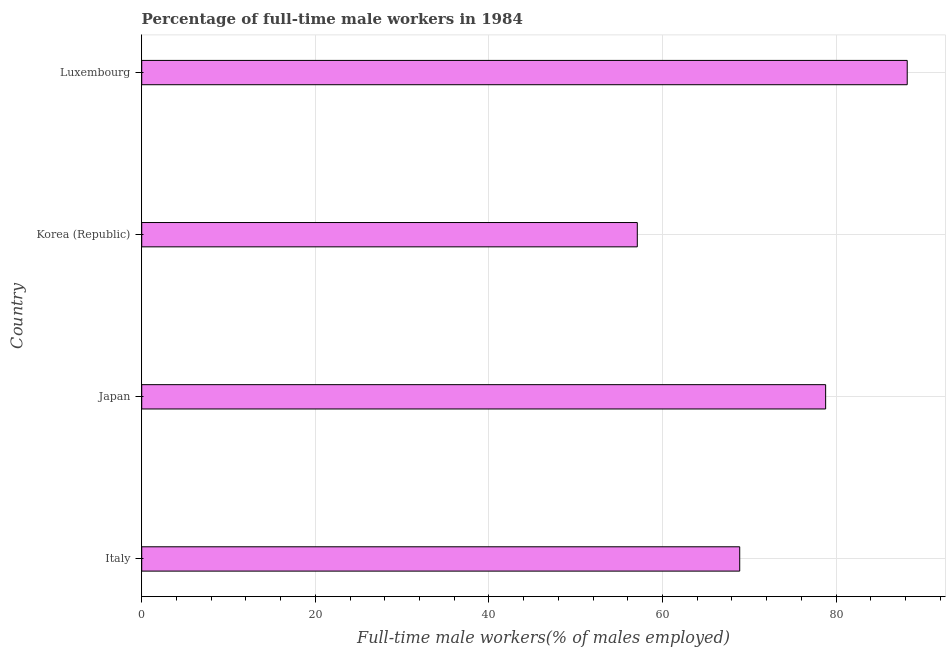What is the title of the graph?
Keep it short and to the point. Percentage of full-time male workers in 1984. What is the label or title of the X-axis?
Offer a terse response. Full-time male workers(% of males employed). What is the label or title of the Y-axis?
Provide a succinct answer. Country. What is the percentage of full-time male workers in Korea (Republic)?
Provide a short and direct response. 57.1. Across all countries, what is the maximum percentage of full-time male workers?
Offer a terse response. 88.2. Across all countries, what is the minimum percentage of full-time male workers?
Ensure brevity in your answer.  57.1. In which country was the percentage of full-time male workers maximum?
Offer a very short reply. Luxembourg. In which country was the percentage of full-time male workers minimum?
Your answer should be very brief. Korea (Republic). What is the sum of the percentage of full-time male workers?
Ensure brevity in your answer.  293. What is the difference between the percentage of full-time male workers in Japan and Korea (Republic)?
Give a very brief answer. 21.7. What is the average percentage of full-time male workers per country?
Provide a succinct answer. 73.25. What is the median percentage of full-time male workers?
Ensure brevity in your answer.  73.85. In how many countries, is the percentage of full-time male workers greater than 16 %?
Make the answer very short. 4. What is the ratio of the percentage of full-time male workers in Italy to that in Luxembourg?
Give a very brief answer. 0.78. Is the percentage of full-time male workers in Japan less than that in Luxembourg?
Ensure brevity in your answer.  Yes. Is the difference between the percentage of full-time male workers in Italy and Luxembourg greater than the difference between any two countries?
Offer a very short reply. No. What is the difference between the highest and the second highest percentage of full-time male workers?
Offer a terse response. 9.4. Is the sum of the percentage of full-time male workers in Italy and Japan greater than the maximum percentage of full-time male workers across all countries?
Your answer should be compact. Yes. What is the difference between the highest and the lowest percentage of full-time male workers?
Provide a succinct answer. 31.1. How many bars are there?
Ensure brevity in your answer.  4. Are all the bars in the graph horizontal?
Keep it short and to the point. Yes. How many countries are there in the graph?
Ensure brevity in your answer.  4. What is the difference between two consecutive major ticks on the X-axis?
Give a very brief answer. 20. Are the values on the major ticks of X-axis written in scientific E-notation?
Make the answer very short. No. What is the Full-time male workers(% of males employed) of Italy?
Make the answer very short. 68.9. What is the Full-time male workers(% of males employed) in Japan?
Offer a terse response. 78.8. What is the Full-time male workers(% of males employed) of Korea (Republic)?
Your answer should be very brief. 57.1. What is the Full-time male workers(% of males employed) in Luxembourg?
Your response must be concise. 88.2. What is the difference between the Full-time male workers(% of males employed) in Italy and Japan?
Ensure brevity in your answer.  -9.9. What is the difference between the Full-time male workers(% of males employed) in Italy and Korea (Republic)?
Make the answer very short. 11.8. What is the difference between the Full-time male workers(% of males employed) in Italy and Luxembourg?
Offer a very short reply. -19.3. What is the difference between the Full-time male workers(% of males employed) in Japan and Korea (Republic)?
Your answer should be very brief. 21.7. What is the difference between the Full-time male workers(% of males employed) in Japan and Luxembourg?
Ensure brevity in your answer.  -9.4. What is the difference between the Full-time male workers(% of males employed) in Korea (Republic) and Luxembourg?
Provide a short and direct response. -31.1. What is the ratio of the Full-time male workers(% of males employed) in Italy to that in Japan?
Ensure brevity in your answer.  0.87. What is the ratio of the Full-time male workers(% of males employed) in Italy to that in Korea (Republic)?
Keep it short and to the point. 1.21. What is the ratio of the Full-time male workers(% of males employed) in Italy to that in Luxembourg?
Ensure brevity in your answer.  0.78. What is the ratio of the Full-time male workers(% of males employed) in Japan to that in Korea (Republic)?
Your response must be concise. 1.38. What is the ratio of the Full-time male workers(% of males employed) in Japan to that in Luxembourg?
Provide a short and direct response. 0.89. What is the ratio of the Full-time male workers(% of males employed) in Korea (Republic) to that in Luxembourg?
Your answer should be compact. 0.65. 